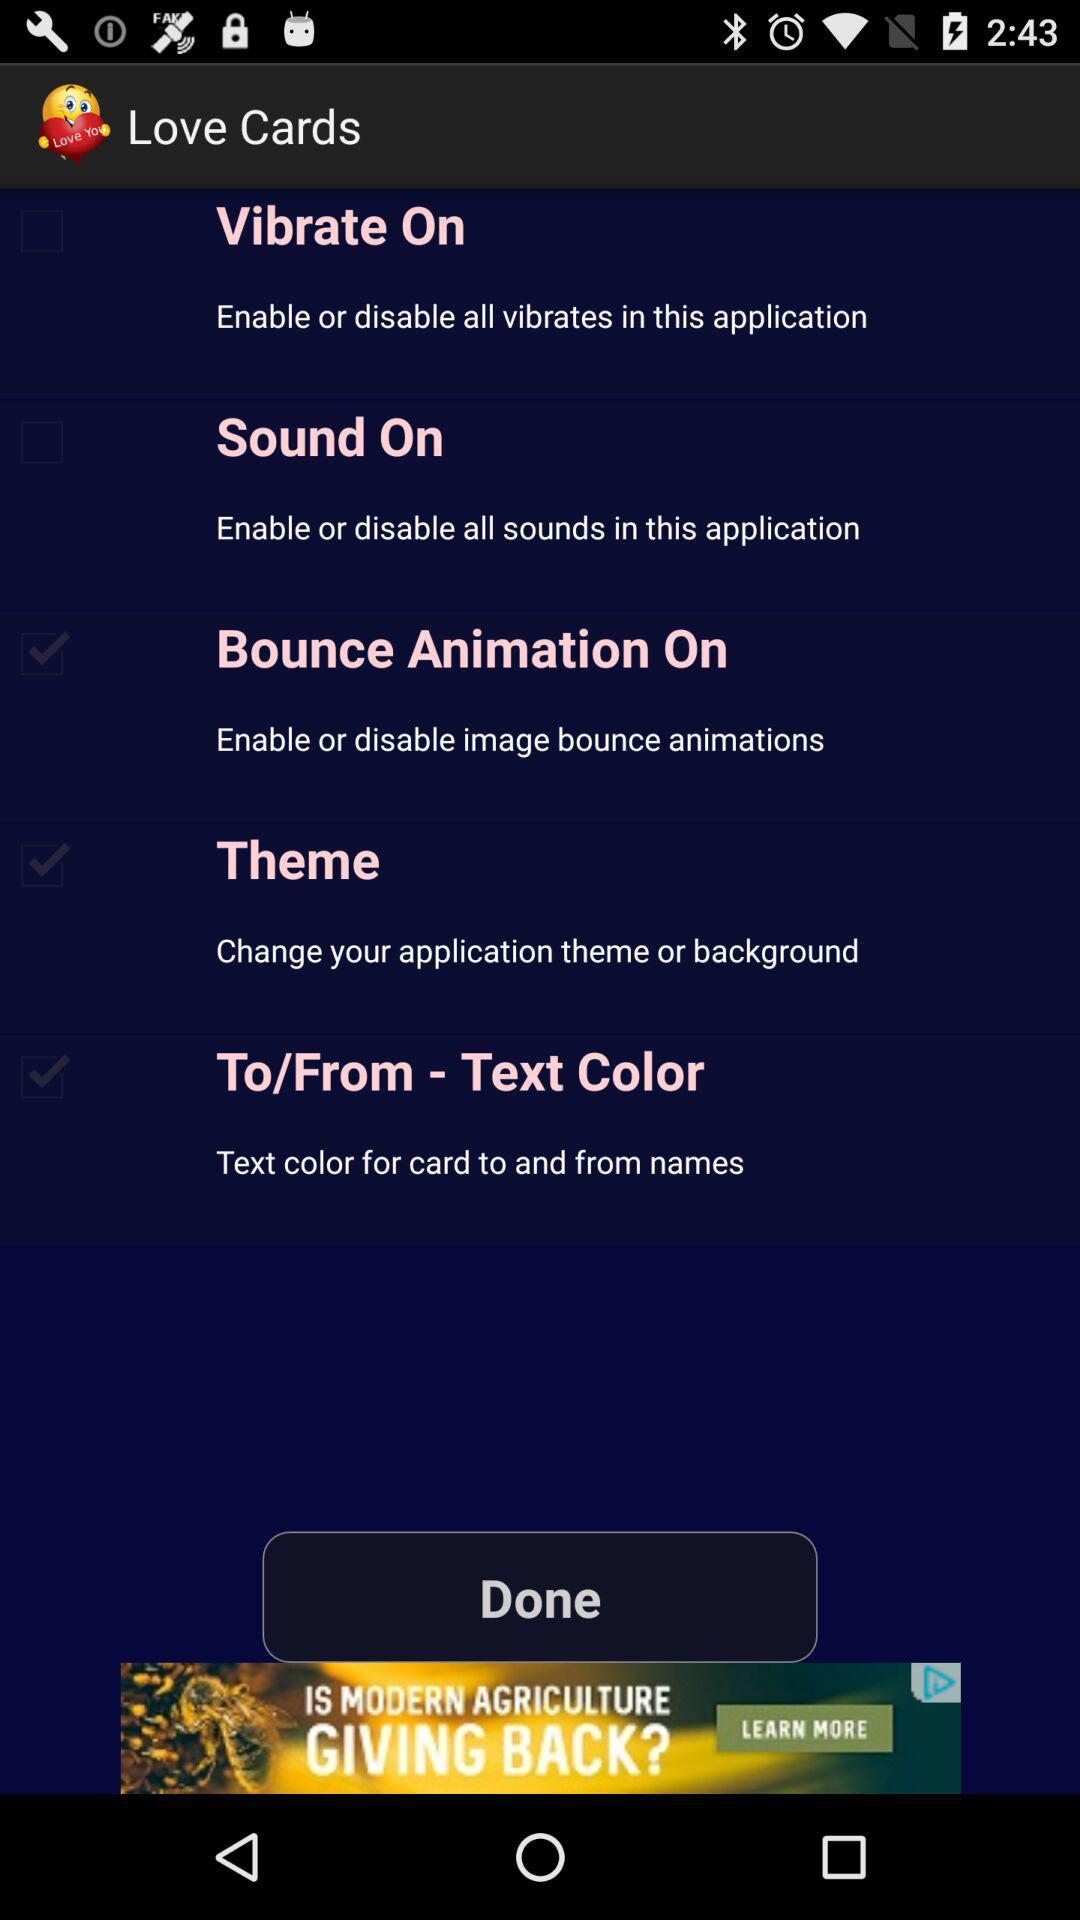What is the status of "Sound On"? The status is "off". 